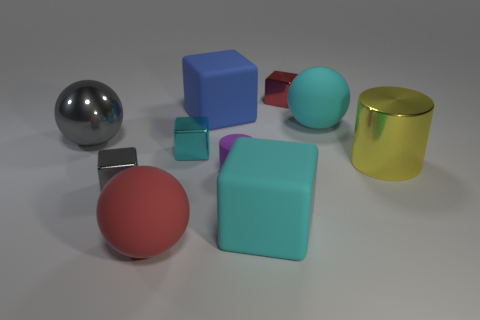How many cubes are tiny red shiny things or large objects?
Offer a very short reply. 3. Are any big brown rubber objects visible?
Offer a very short reply. No. What number of other things are there of the same material as the tiny red block
Give a very brief answer. 4. What material is the cyan block that is the same size as the red ball?
Your answer should be compact. Rubber. Does the red object behind the big gray metal thing have the same shape as the blue rubber thing?
Your answer should be compact. Yes. What number of things are big objects behind the cyan ball or blue cylinders?
Your response must be concise. 1. The blue object that is the same size as the red matte sphere is what shape?
Ensure brevity in your answer.  Cube. There is a metallic block behind the gray ball; does it have the same size as the cyan cube behind the yellow metal cylinder?
Ensure brevity in your answer.  Yes. The large cube that is made of the same material as the blue object is what color?
Keep it short and to the point. Cyan. Are the red thing behind the red matte object and the big cylinder on the right side of the small cyan metallic block made of the same material?
Make the answer very short. Yes. 